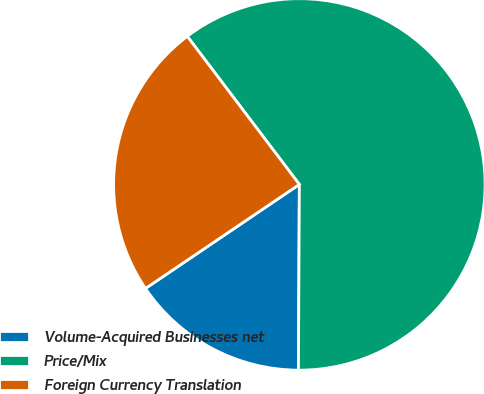<chart> <loc_0><loc_0><loc_500><loc_500><pie_chart><fcel>Volume-Acquired Businesses net<fcel>Price/Mix<fcel>Foreign Currency Translation<nl><fcel>15.46%<fcel>60.39%<fcel>24.15%<nl></chart> 